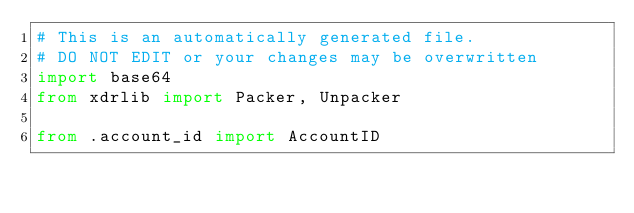Convert code to text. <code><loc_0><loc_0><loc_500><loc_500><_Python_># This is an automatically generated file.
# DO NOT EDIT or your changes may be overwritten
import base64
from xdrlib import Packer, Unpacker

from .account_id import AccountID</code> 